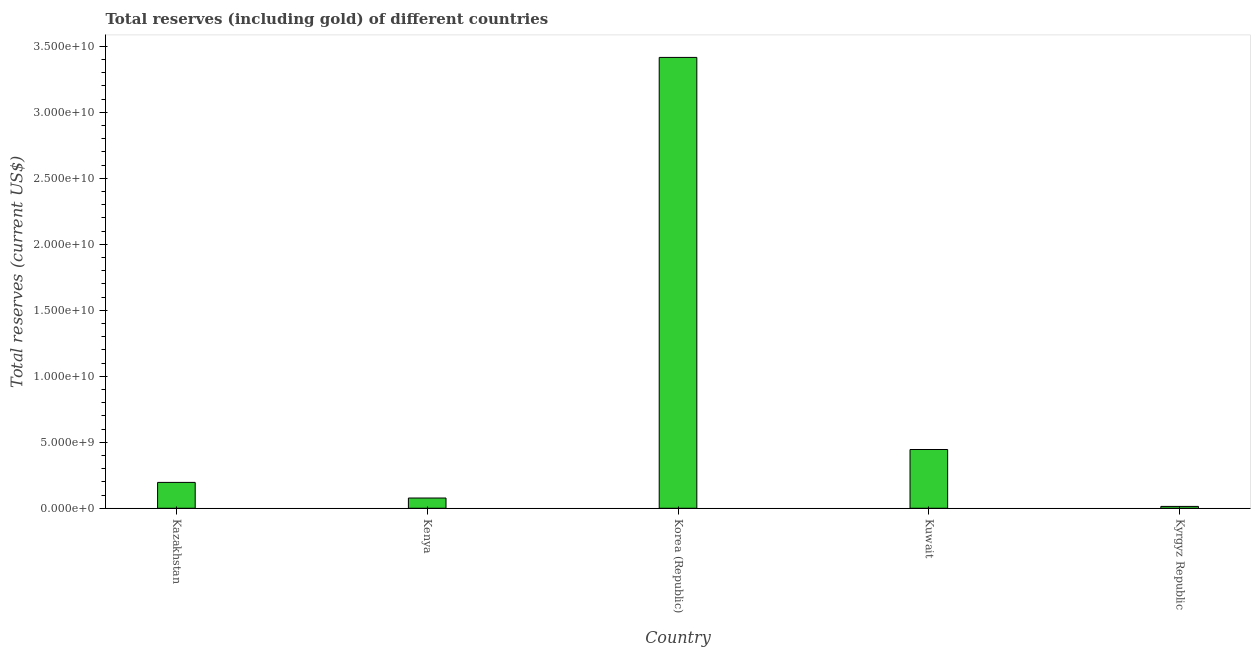Does the graph contain any zero values?
Give a very brief answer. No. Does the graph contain grids?
Give a very brief answer. No. What is the title of the graph?
Your answer should be very brief. Total reserves (including gold) of different countries. What is the label or title of the Y-axis?
Provide a succinct answer. Total reserves (current US$). What is the total reserves (including gold) in Kuwait?
Keep it short and to the point. 4.45e+09. Across all countries, what is the maximum total reserves (including gold)?
Your response must be concise. 3.42e+1. Across all countries, what is the minimum total reserves (including gold)?
Your answer should be compact. 1.40e+08. In which country was the total reserves (including gold) maximum?
Keep it short and to the point. Korea (Republic). In which country was the total reserves (including gold) minimum?
Provide a succinct answer. Kyrgyz Republic. What is the sum of the total reserves (including gold)?
Give a very brief answer. 4.15e+1. What is the difference between the total reserves (including gold) in Kuwait and Kyrgyz Republic?
Provide a succinct answer. 4.31e+09. What is the average total reserves (including gold) per country?
Provide a succinct answer. 8.30e+09. What is the median total reserves (including gold)?
Your response must be concise. 1.96e+09. In how many countries, is the total reserves (including gold) greater than 18000000000 US$?
Give a very brief answer. 1. What is the ratio of the total reserves (including gold) in Kuwait to that in Kyrgyz Republic?
Give a very brief answer. 31.76. Is the difference between the total reserves (including gold) in Kazakhstan and Kuwait greater than the difference between any two countries?
Your answer should be very brief. No. What is the difference between the highest and the second highest total reserves (including gold)?
Give a very brief answer. 2.97e+1. Is the sum of the total reserves (including gold) in Kenya and Kyrgyz Republic greater than the maximum total reserves (including gold) across all countries?
Keep it short and to the point. No. What is the difference between the highest and the lowest total reserves (including gold)?
Your answer should be very brief. 3.40e+1. In how many countries, is the total reserves (including gold) greater than the average total reserves (including gold) taken over all countries?
Make the answer very short. 1. How many bars are there?
Ensure brevity in your answer.  5. Are all the bars in the graph horizontal?
Provide a succinct answer. No. How many countries are there in the graph?
Give a very brief answer. 5. What is the Total reserves (current US$) in Kazakhstan?
Provide a short and direct response. 1.96e+09. What is the Total reserves (current US$) of Kenya?
Your answer should be very brief. 7.76e+08. What is the Total reserves (current US$) of Korea (Republic)?
Your answer should be compact. 3.42e+1. What is the Total reserves (current US$) in Kuwait?
Provide a short and direct response. 4.45e+09. What is the Total reserves (current US$) in Kyrgyz Republic?
Provide a short and direct response. 1.40e+08. What is the difference between the Total reserves (current US$) in Kazakhstan and Kenya?
Ensure brevity in your answer.  1.18e+09. What is the difference between the Total reserves (current US$) in Kazakhstan and Korea (Republic)?
Give a very brief answer. -3.22e+1. What is the difference between the Total reserves (current US$) in Kazakhstan and Kuwait?
Offer a terse response. -2.49e+09. What is the difference between the Total reserves (current US$) in Kazakhstan and Kyrgyz Republic?
Your response must be concise. 1.82e+09. What is the difference between the Total reserves (current US$) in Kenya and Korea (Republic)?
Keep it short and to the point. -3.34e+1. What is the difference between the Total reserves (current US$) in Kenya and Kuwait?
Your answer should be compact. -3.68e+09. What is the difference between the Total reserves (current US$) in Kenya and Kyrgyz Republic?
Offer a terse response. 6.36e+08. What is the difference between the Total reserves (current US$) in Korea (Republic) and Kuwait?
Your answer should be compact. 2.97e+1. What is the difference between the Total reserves (current US$) in Korea (Republic) and Kyrgyz Republic?
Provide a short and direct response. 3.40e+1. What is the difference between the Total reserves (current US$) in Kuwait and Kyrgyz Republic?
Your answer should be very brief. 4.31e+09. What is the ratio of the Total reserves (current US$) in Kazakhstan to that in Kenya?
Your answer should be compact. 2.53. What is the ratio of the Total reserves (current US$) in Kazakhstan to that in Korea (Republic)?
Offer a very short reply. 0.06. What is the ratio of the Total reserves (current US$) in Kazakhstan to that in Kuwait?
Offer a very short reply. 0.44. What is the ratio of the Total reserves (current US$) in Kazakhstan to that in Kyrgyz Republic?
Offer a very short reply. 13.98. What is the ratio of the Total reserves (current US$) in Kenya to that in Korea (Republic)?
Offer a terse response. 0.02. What is the ratio of the Total reserves (current US$) in Kenya to that in Kuwait?
Provide a short and direct response. 0.17. What is the ratio of the Total reserves (current US$) in Kenya to that in Kyrgyz Republic?
Offer a very short reply. 5.53. What is the ratio of the Total reserves (current US$) in Korea (Republic) to that in Kuwait?
Your answer should be compact. 7.67. What is the ratio of the Total reserves (current US$) in Korea (Republic) to that in Kyrgyz Republic?
Your response must be concise. 243.64. What is the ratio of the Total reserves (current US$) in Kuwait to that in Kyrgyz Republic?
Provide a short and direct response. 31.76. 